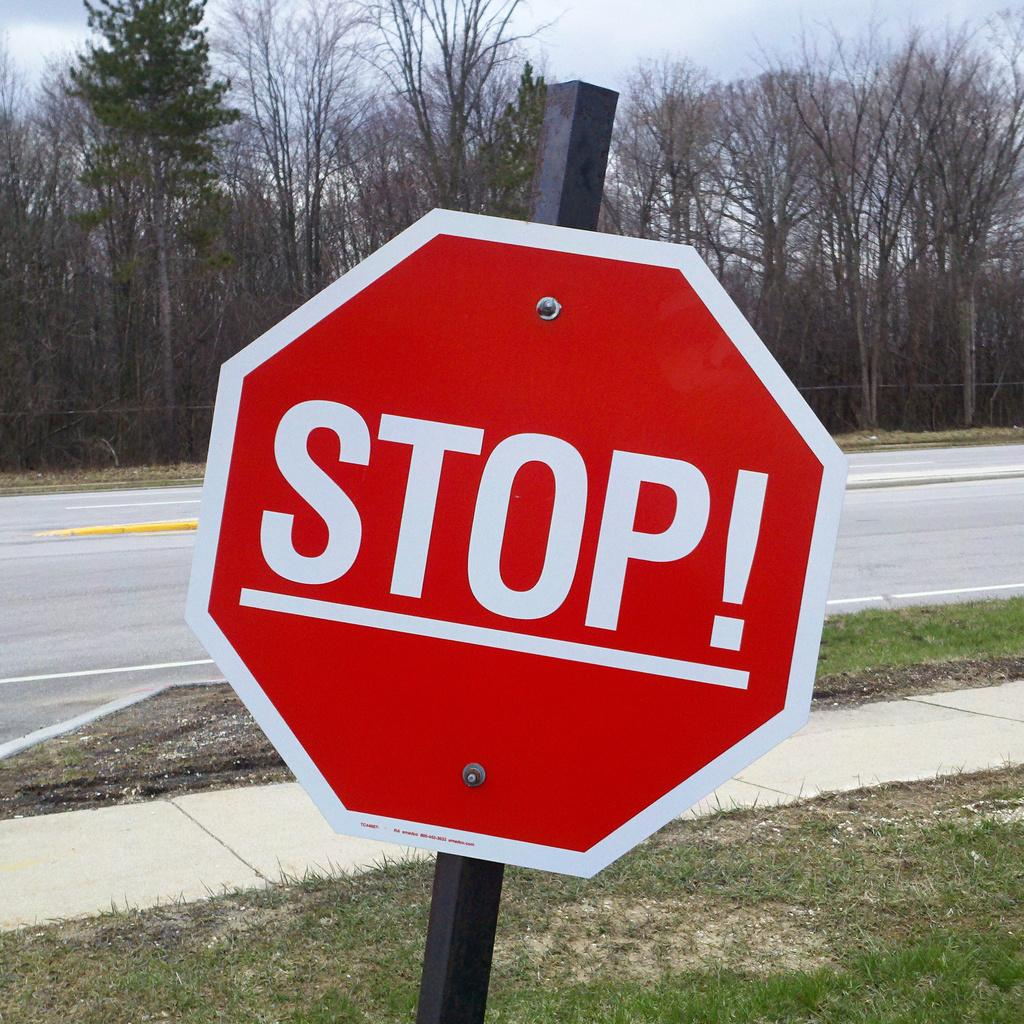<image>
Create a compact narrative representing the image presented. A stop sign is slightly slanted to the right, just before the side walk. 